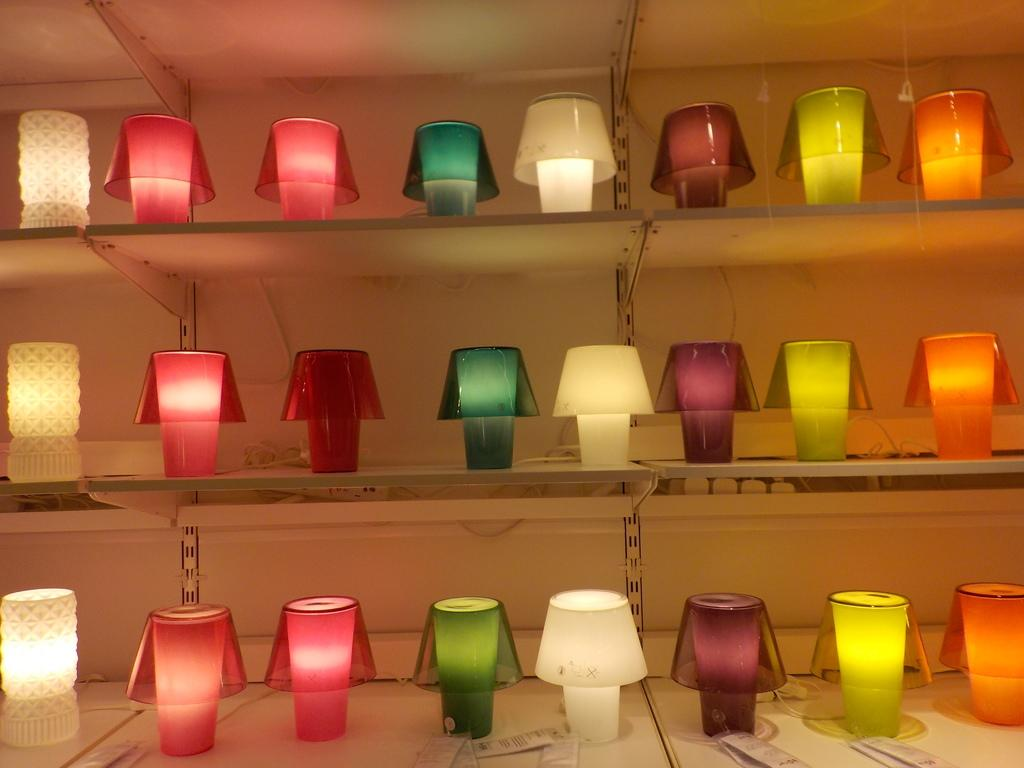What is present on the shelves in the image? There are lights on the shelves in the image. Can you describe any additional details about the image? There are tags visible at the bottom side of the image. How many crows are sitting on the lights in the image? There are no crows present in the image; it only features lights on the shelves and tags at the bottom. 